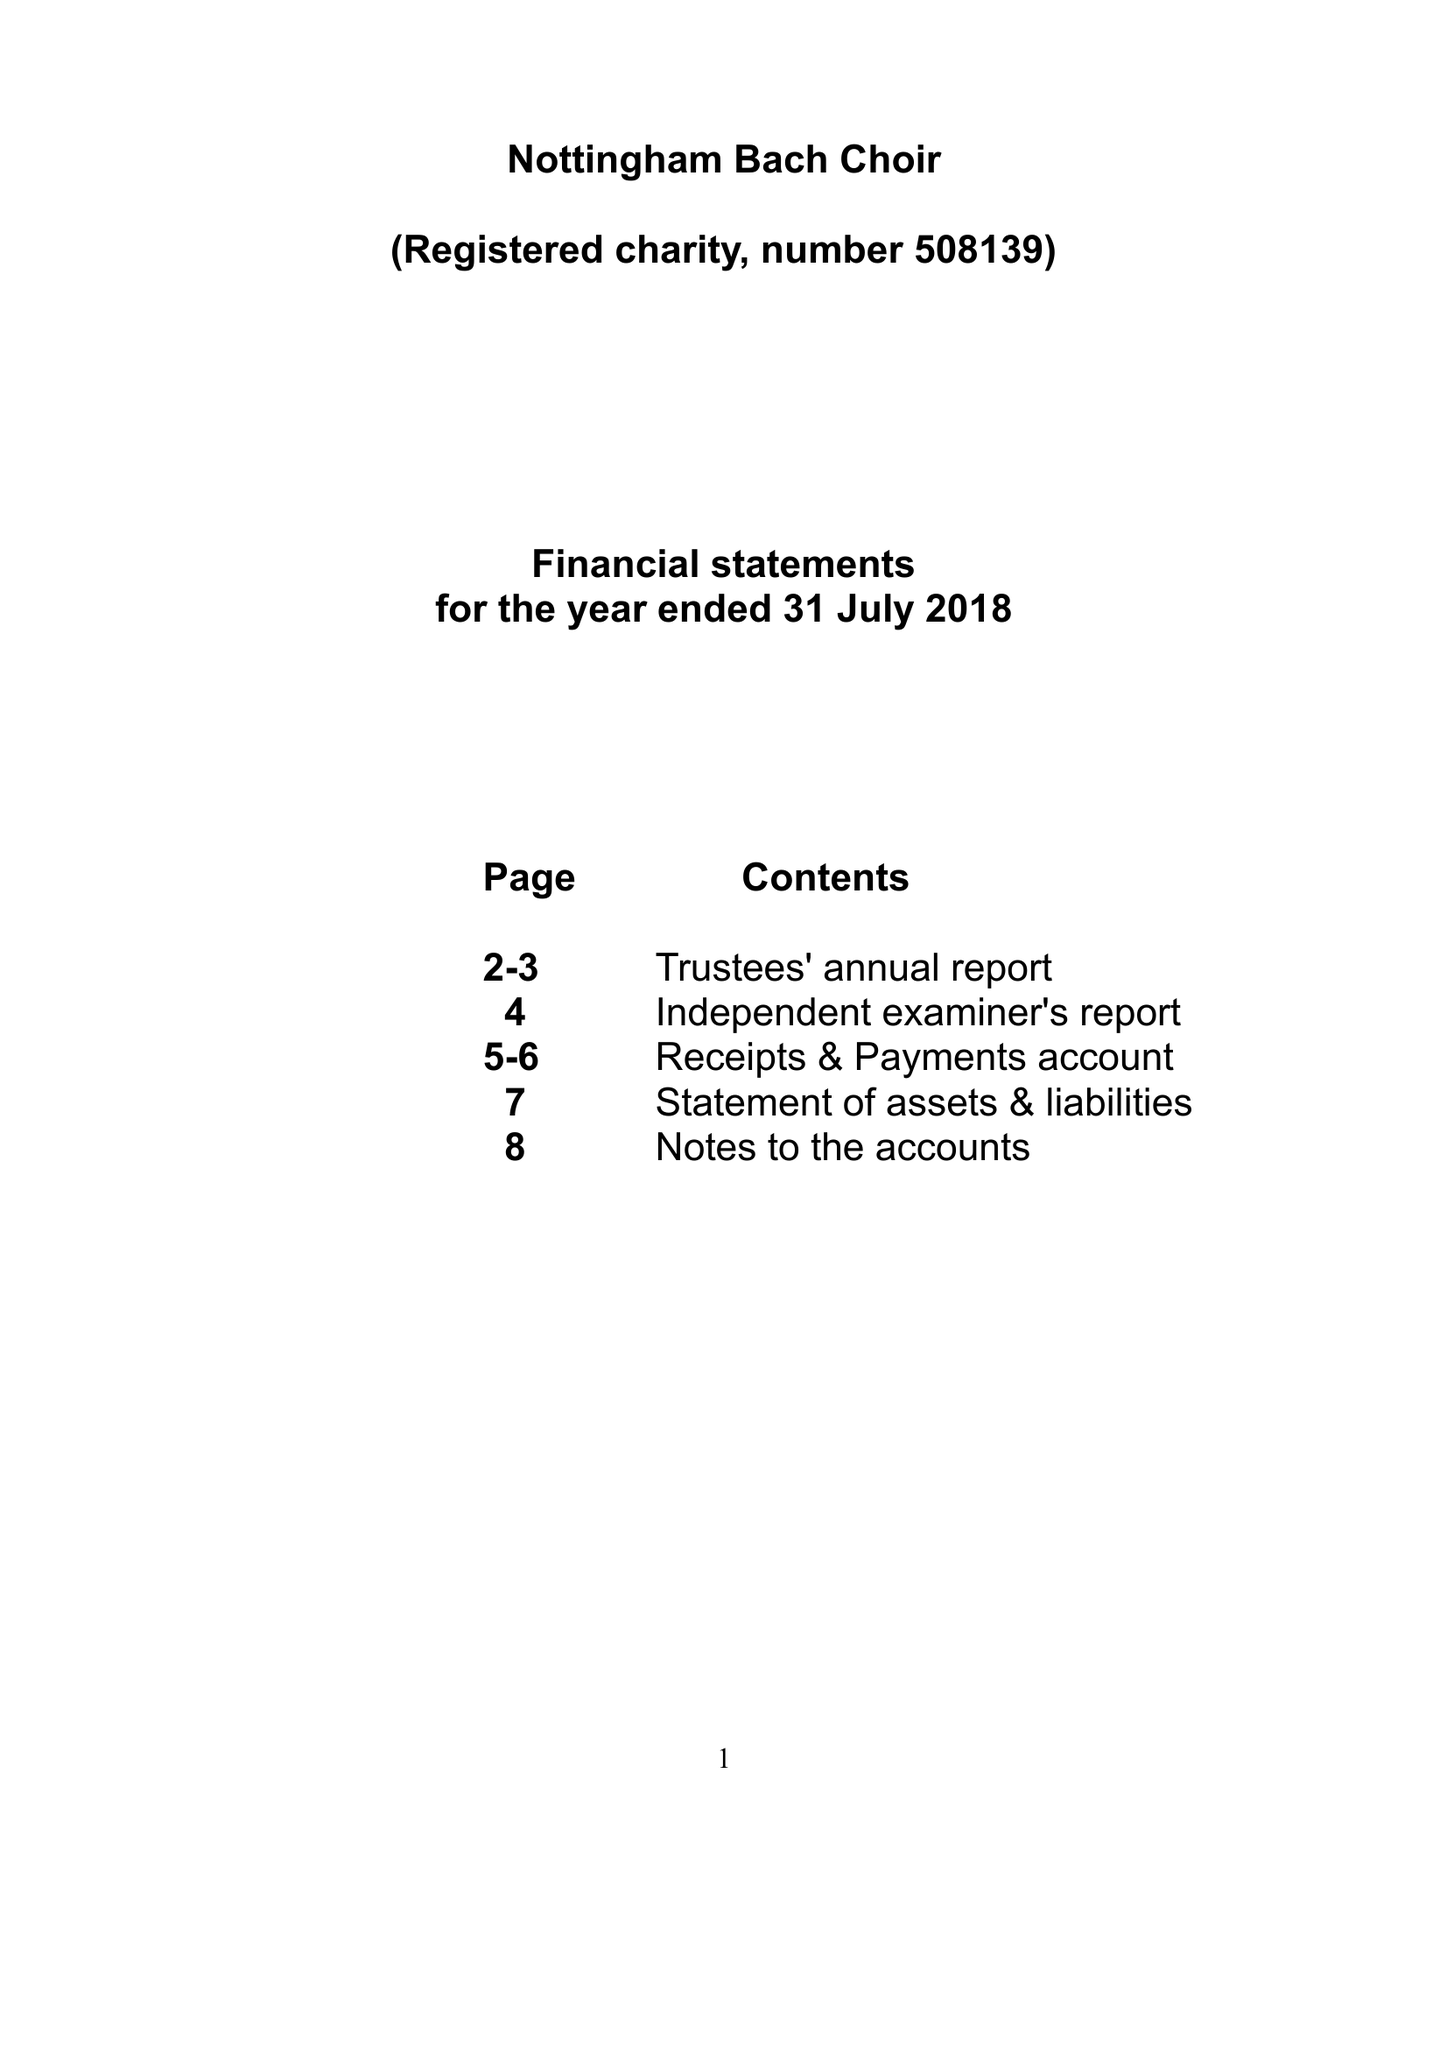What is the value for the address__street_line?
Answer the question using a single word or phrase. 10 MERCURY CLOSE 